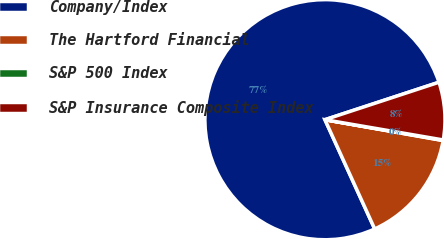<chart> <loc_0><loc_0><loc_500><loc_500><pie_chart><fcel>Company/Index<fcel>The Hartford Financial<fcel>S&P 500 Index<fcel>S&P Insurance Composite Index<nl><fcel>76.76%<fcel>15.42%<fcel>0.08%<fcel>7.75%<nl></chart> 